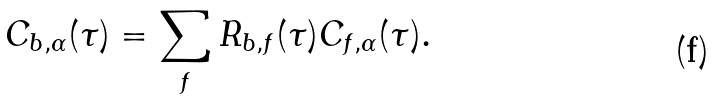Convert formula to latex. <formula><loc_0><loc_0><loc_500><loc_500>C _ { b , \alpha } ( \tau ) = \sum _ { f } R _ { b , f } ( \tau ) C _ { f , \alpha } ( \tau ) .</formula> 